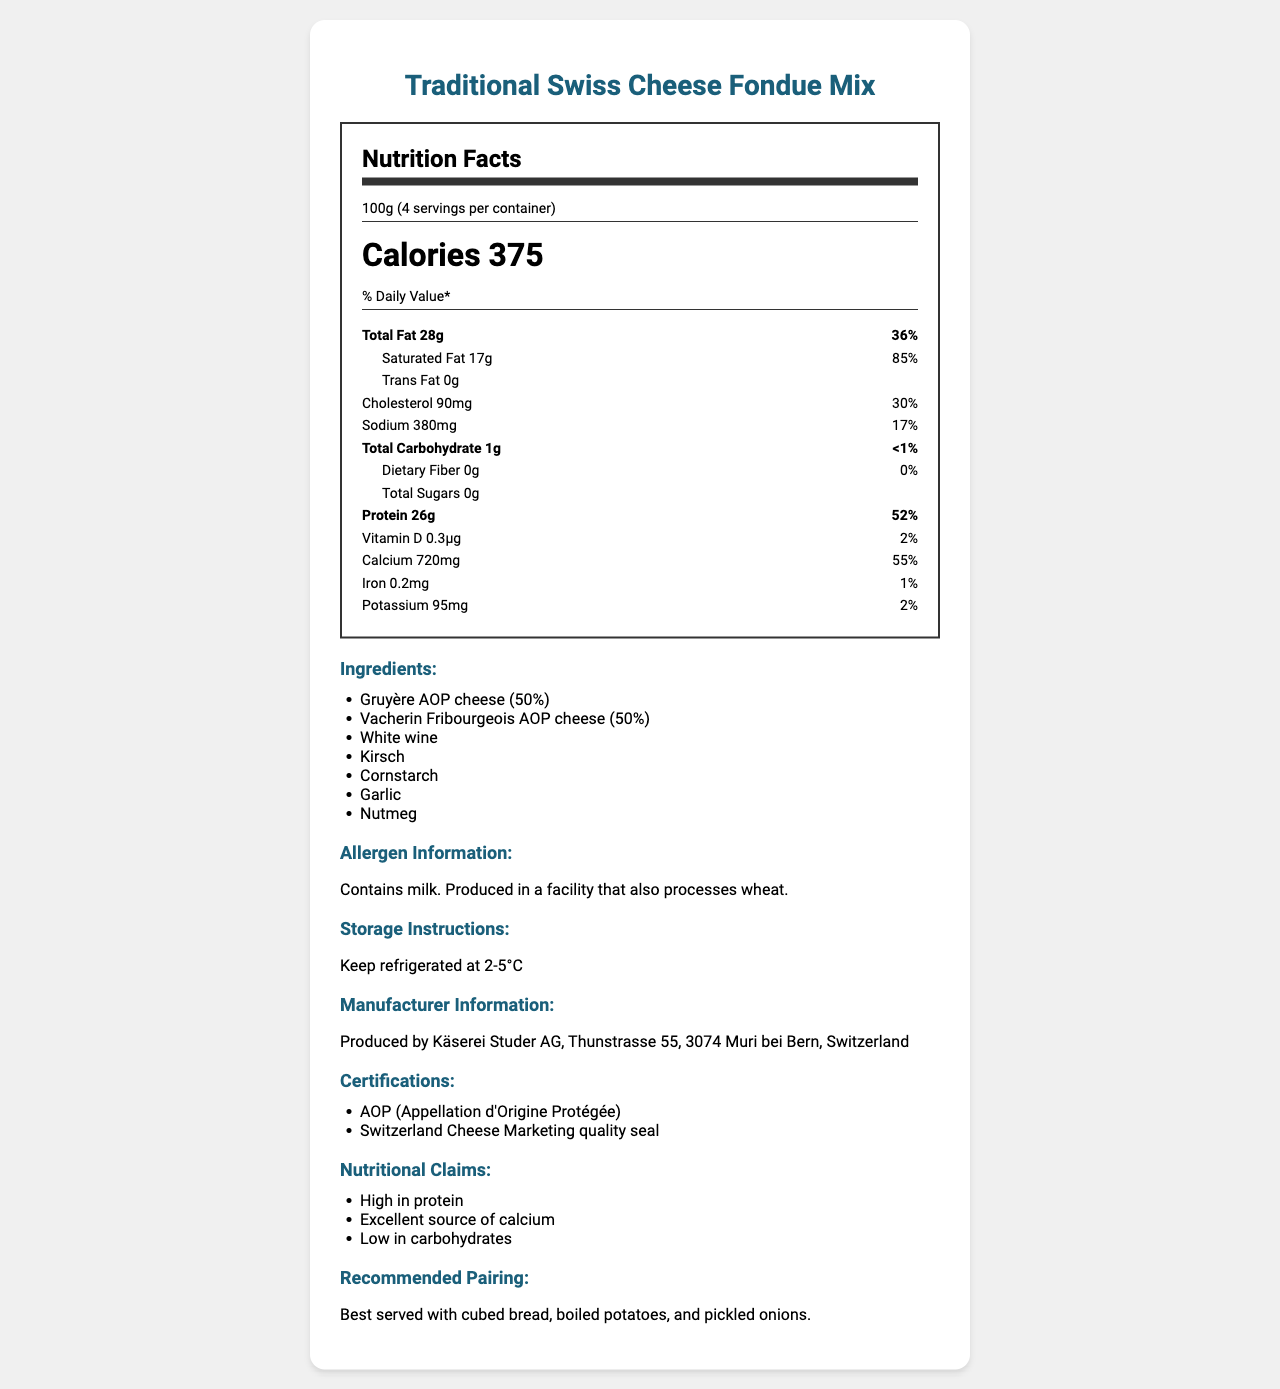who is the manufacturer of the traditional Swiss cheese fondue mix? The manufacturer's information is detailed in the section labeled "Manufacturer Information."
Answer: Käserei Studer AG how many calories are in one serving of the fondue mix? The calories per serving are specified as 375 calories in the document.
Answer: 375 how much saturated fat does one serving of the fondue mix contain? The amount of saturated fat per serving is listed as 17 grams.
Answer: 17g what is the serving size for the fondue mix? The serving size is specified as 100 grams.
Answer: 100g which ingredient is listed first in the fondue mix? The ingredients list starts with Gruyère AOP cheese (50%).
Answer: Gruyère AOP cheese how many servings are there in one container of the fondue mix? The document notes that there are 4 servings per container.
Answer: 4 what percentage of the daily value of calcium is provided per serving of the fondue mix? The daily value percentage for calcium is listed as 55%.
Answer: 55% does the fondue mix contain any dietary fiber? The document states that the dietary fiber amount is 0g, and the daily value is 0%.
Answer: No how much protein is in one serving of the fondue mix? The amount of protein per serving is listed as 26 grams.
Answer: 26g what allergen information is provided for the fondue mix? The allergen information is clearly stated in the document.
Answer: Contains milk. Produced in a facility that also processes wheat. what is the recommended storage temperature for the fondue mix? The storage instructions specify keeping the product refrigerated at 2-5°C.
Answer: 2-5°C how much potassium is in one serving of the fondue mix? A. 95mg B. 100mg C. 90mg The document lists the potassium content as 95mg per serving.
Answer: A. 95mg how much cholesterol is in one serving of the fondue mix? A. 80mg B. 85mg C. 90mg D. 95mg The cholesterol content per serving is specified as 90mg.
Answer: C. 90mg how much iron is in one serving of the fondue mix? A. 0.1mg B. 0.2mg C. 0.3mg D. 0.4mg The document indicates that the iron content is 0.2mg per serving.
Answer: B. 0.2mg is the fondue mix high in protein? The nutritional claims summary states that the product is high in protein.
Answer: Yes does the fondue mix contain any added sugars? The document states that the total sugars content is 0g, indicating no added sugars.
Answer: No what certifications does the fondue mix have? The certifications are listed in the document under the certifications section.
Answer: AOP (Appellation d'Origine Protégée), Switzerland Cheese Marketing quality seal what are the key nutrients provided per serving of the fondue mix? The key nutrients are highlighted with their respective daily values and amounts.
Answer: Protein, Calcium, Total Fat, Saturated Fat, Cholesterol, Sodium what pairing is recommended for serving the fondue? The document recommends pairing the fondue with cubed bread, boiled potatoes, and pickled onions.
Answer: Cubed bread, boiled potatoes, and pickled onions describe the main idea of the document. The document offers comprehensive information about the product, including nutritional content, ingredients, and suggested pairings, aimed at helping consumers understand and properly use the product.
Answer: The document provides detailed nutrition facts, ingredients, allergen information, storage instructions, manufacturer info, certifications, nutritional claims, and recommended pairings for a Traditional Swiss Cheese Fondue Mix. what is the production facility's address? The document provides the manufacturer's address but not the specific production facility address.
Answer: Cannot be determined 